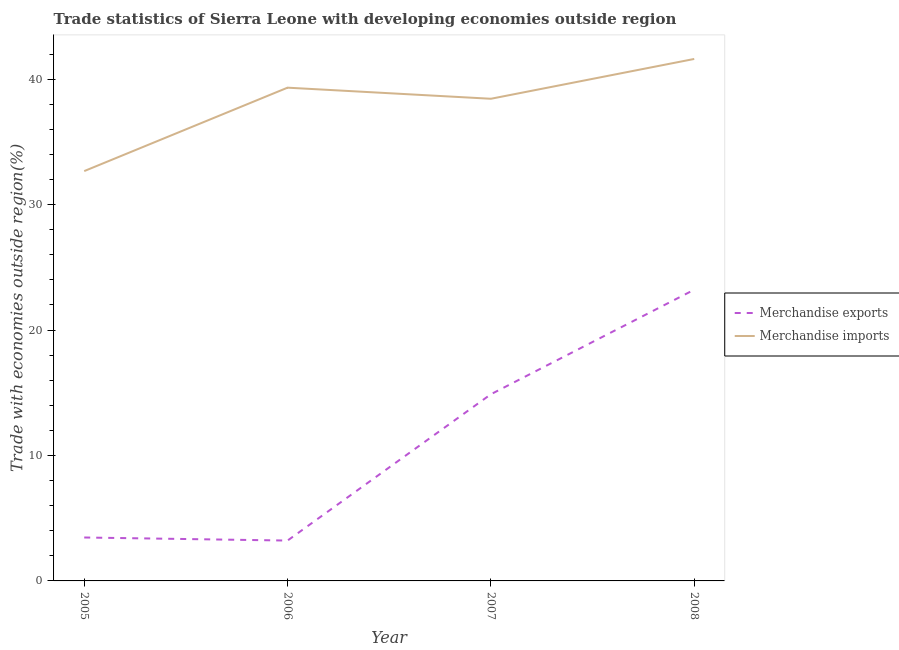How many different coloured lines are there?
Give a very brief answer. 2. Is the number of lines equal to the number of legend labels?
Make the answer very short. Yes. What is the merchandise exports in 2008?
Provide a short and direct response. 23.22. Across all years, what is the maximum merchandise exports?
Ensure brevity in your answer.  23.22. Across all years, what is the minimum merchandise imports?
Offer a terse response. 32.67. In which year was the merchandise exports minimum?
Provide a succinct answer. 2006. What is the total merchandise imports in the graph?
Make the answer very short. 152.03. What is the difference between the merchandise imports in 2005 and that in 2007?
Keep it short and to the point. -5.77. What is the difference between the merchandise exports in 2007 and the merchandise imports in 2005?
Provide a short and direct response. -17.79. What is the average merchandise imports per year?
Offer a very short reply. 38.01. In the year 2005, what is the difference between the merchandise imports and merchandise exports?
Offer a terse response. 29.21. What is the ratio of the merchandise imports in 2005 to that in 2006?
Provide a succinct answer. 0.83. What is the difference between the highest and the second highest merchandise imports?
Offer a very short reply. 2.29. What is the difference between the highest and the lowest merchandise exports?
Provide a succinct answer. 20. In how many years, is the merchandise exports greater than the average merchandise exports taken over all years?
Provide a short and direct response. 2. Does the merchandise imports monotonically increase over the years?
Give a very brief answer. No. Is the merchandise imports strictly less than the merchandise exports over the years?
Make the answer very short. No. How many years are there in the graph?
Provide a succinct answer. 4. Does the graph contain any zero values?
Make the answer very short. No. Where does the legend appear in the graph?
Ensure brevity in your answer.  Center right. How many legend labels are there?
Ensure brevity in your answer.  2. How are the legend labels stacked?
Offer a terse response. Vertical. What is the title of the graph?
Give a very brief answer. Trade statistics of Sierra Leone with developing economies outside region. What is the label or title of the Y-axis?
Your answer should be compact. Trade with economies outside region(%). What is the Trade with economies outside region(%) of Merchandise exports in 2005?
Make the answer very short. 3.46. What is the Trade with economies outside region(%) in Merchandise imports in 2005?
Offer a terse response. 32.67. What is the Trade with economies outside region(%) of Merchandise exports in 2006?
Make the answer very short. 3.22. What is the Trade with economies outside region(%) in Merchandise imports in 2006?
Keep it short and to the point. 39.32. What is the Trade with economies outside region(%) in Merchandise exports in 2007?
Ensure brevity in your answer.  14.88. What is the Trade with economies outside region(%) of Merchandise imports in 2007?
Keep it short and to the point. 38.44. What is the Trade with economies outside region(%) of Merchandise exports in 2008?
Offer a very short reply. 23.22. What is the Trade with economies outside region(%) of Merchandise imports in 2008?
Offer a terse response. 41.61. Across all years, what is the maximum Trade with economies outside region(%) of Merchandise exports?
Give a very brief answer. 23.22. Across all years, what is the maximum Trade with economies outside region(%) of Merchandise imports?
Your answer should be compact. 41.61. Across all years, what is the minimum Trade with economies outside region(%) in Merchandise exports?
Your answer should be very brief. 3.22. Across all years, what is the minimum Trade with economies outside region(%) of Merchandise imports?
Give a very brief answer. 32.67. What is the total Trade with economies outside region(%) in Merchandise exports in the graph?
Offer a very short reply. 44.78. What is the total Trade with economies outside region(%) of Merchandise imports in the graph?
Provide a succinct answer. 152.03. What is the difference between the Trade with economies outside region(%) of Merchandise exports in 2005 and that in 2006?
Provide a succinct answer. 0.24. What is the difference between the Trade with economies outside region(%) of Merchandise imports in 2005 and that in 2006?
Provide a succinct answer. -6.65. What is the difference between the Trade with economies outside region(%) of Merchandise exports in 2005 and that in 2007?
Offer a terse response. -11.42. What is the difference between the Trade with economies outside region(%) in Merchandise imports in 2005 and that in 2007?
Provide a succinct answer. -5.77. What is the difference between the Trade with economies outside region(%) of Merchandise exports in 2005 and that in 2008?
Offer a terse response. -19.75. What is the difference between the Trade with economies outside region(%) in Merchandise imports in 2005 and that in 2008?
Provide a succinct answer. -8.94. What is the difference between the Trade with economies outside region(%) in Merchandise exports in 2006 and that in 2007?
Offer a terse response. -11.66. What is the difference between the Trade with economies outside region(%) of Merchandise imports in 2006 and that in 2007?
Provide a succinct answer. 0.88. What is the difference between the Trade with economies outside region(%) of Merchandise exports in 2006 and that in 2008?
Make the answer very short. -20. What is the difference between the Trade with economies outside region(%) of Merchandise imports in 2006 and that in 2008?
Your answer should be very brief. -2.29. What is the difference between the Trade with economies outside region(%) in Merchandise exports in 2007 and that in 2008?
Offer a very short reply. -8.33. What is the difference between the Trade with economies outside region(%) of Merchandise imports in 2007 and that in 2008?
Your answer should be compact. -3.17. What is the difference between the Trade with economies outside region(%) of Merchandise exports in 2005 and the Trade with economies outside region(%) of Merchandise imports in 2006?
Your answer should be compact. -35.86. What is the difference between the Trade with economies outside region(%) in Merchandise exports in 2005 and the Trade with economies outside region(%) in Merchandise imports in 2007?
Ensure brevity in your answer.  -34.97. What is the difference between the Trade with economies outside region(%) of Merchandise exports in 2005 and the Trade with economies outside region(%) of Merchandise imports in 2008?
Keep it short and to the point. -38.15. What is the difference between the Trade with economies outside region(%) of Merchandise exports in 2006 and the Trade with economies outside region(%) of Merchandise imports in 2007?
Give a very brief answer. -35.22. What is the difference between the Trade with economies outside region(%) in Merchandise exports in 2006 and the Trade with economies outside region(%) in Merchandise imports in 2008?
Ensure brevity in your answer.  -38.39. What is the difference between the Trade with economies outside region(%) of Merchandise exports in 2007 and the Trade with economies outside region(%) of Merchandise imports in 2008?
Provide a succinct answer. -26.73. What is the average Trade with economies outside region(%) of Merchandise exports per year?
Provide a short and direct response. 11.19. What is the average Trade with economies outside region(%) of Merchandise imports per year?
Provide a short and direct response. 38.01. In the year 2005, what is the difference between the Trade with economies outside region(%) in Merchandise exports and Trade with economies outside region(%) in Merchandise imports?
Your answer should be compact. -29.21. In the year 2006, what is the difference between the Trade with economies outside region(%) in Merchandise exports and Trade with economies outside region(%) in Merchandise imports?
Offer a very short reply. -36.1. In the year 2007, what is the difference between the Trade with economies outside region(%) of Merchandise exports and Trade with economies outside region(%) of Merchandise imports?
Ensure brevity in your answer.  -23.55. In the year 2008, what is the difference between the Trade with economies outside region(%) in Merchandise exports and Trade with economies outside region(%) in Merchandise imports?
Provide a succinct answer. -18.39. What is the ratio of the Trade with economies outside region(%) of Merchandise exports in 2005 to that in 2006?
Offer a very short reply. 1.08. What is the ratio of the Trade with economies outside region(%) in Merchandise imports in 2005 to that in 2006?
Your answer should be compact. 0.83. What is the ratio of the Trade with economies outside region(%) of Merchandise exports in 2005 to that in 2007?
Make the answer very short. 0.23. What is the ratio of the Trade with economies outside region(%) of Merchandise exports in 2005 to that in 2008?
Your answer should be compact. 0.15. What is the ratio of the Trade with economies outside region(%) of Merchandise imports in 2005 to that in 2008?
Offer a terse response. 0.79. What is the ratio of the Trade with economies outside region(%) of Merchandise exports in 2006 to that in 2007?
Offer a terse response. 0.22. What is the ratio of the Trade with economies outside region(%) in Merchandise imports in 2006 to that in 2007?
Offer a very short reply. 1.02. What is the ratio of the Trade with economies outside region(%) in Merchandise exports in 2006 to that in 2008?
Your answer should be very brief. 0.14. What is the ratio of the Trade with economies outside region(%) of Merchandise imports in 2006 to that in 2008?
Provide a short and direct response. 0.94. What is the ratio of the Trade with economies outside region(%) in Merchandise exports in 2007 to that in 2008?
Offer a very short reply. 0.64. What is the ratio of the Trade with economies outside region(%) of Merchandise imports in 2007 to that in 2008?
Your answer should be very brief. 0.92. What is the difference between the highest and the second highest Trade with economies outside region(%) in Merchandise exports?
Ensure brevity in your answer.  8.33. What is the difference between the highest and the second highest Trade with economies outside region(%) of Merchandise imports?
Provide a short and direct response. 2.29. What is the difference between the highest and the lowest Trade with economies outside region(%) of Merchandise exports?
Your answer should be compact. 20. What is the difference between the highest and the lowest Trade with economies outside region(%) of Merchandise imports?
Your response must be concise. 8.94. 